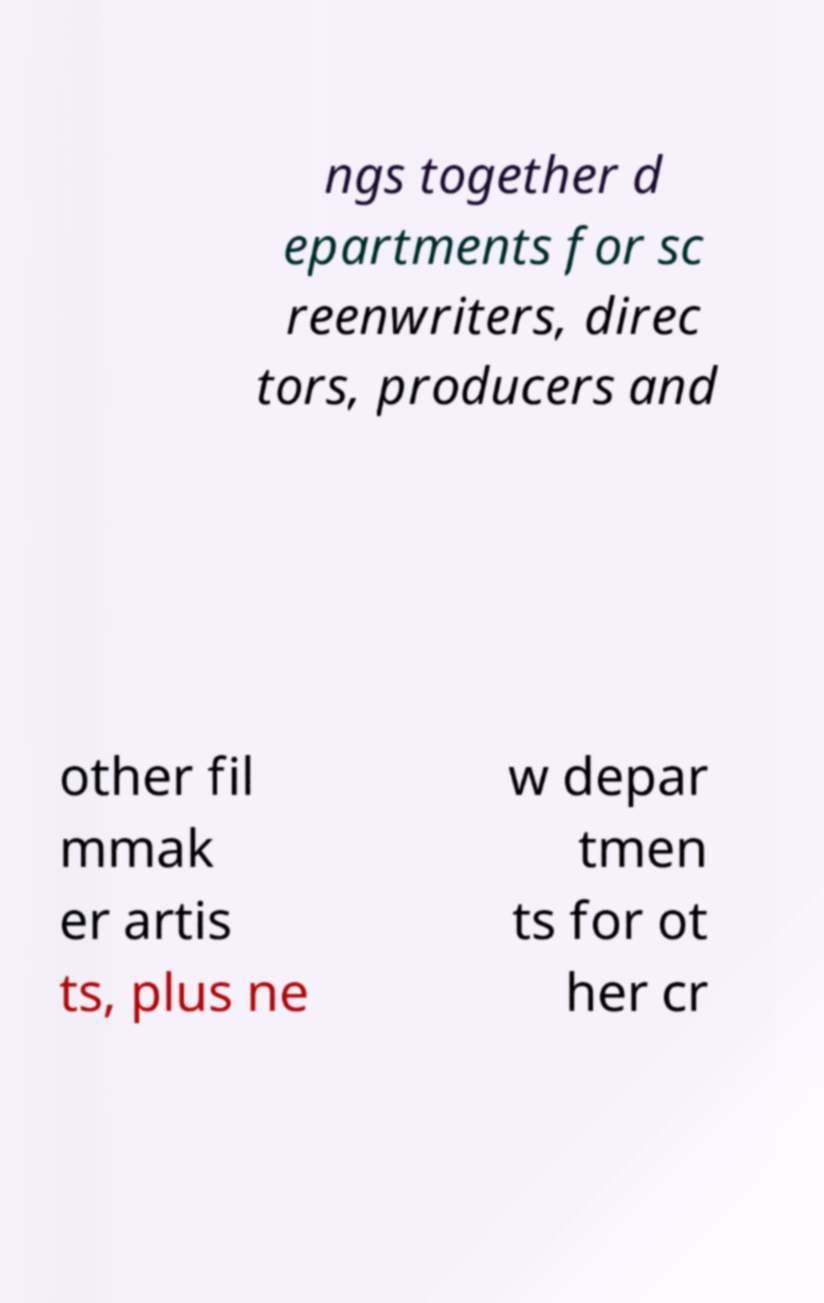There's text embedded in this image that I need extracted. Can you transcribe it verbatim? ngs together d epartments for sc reenwriters, direc tors, producers and other fil mmak er artis ts, plus ne w depar tmen ts for ot her cr 